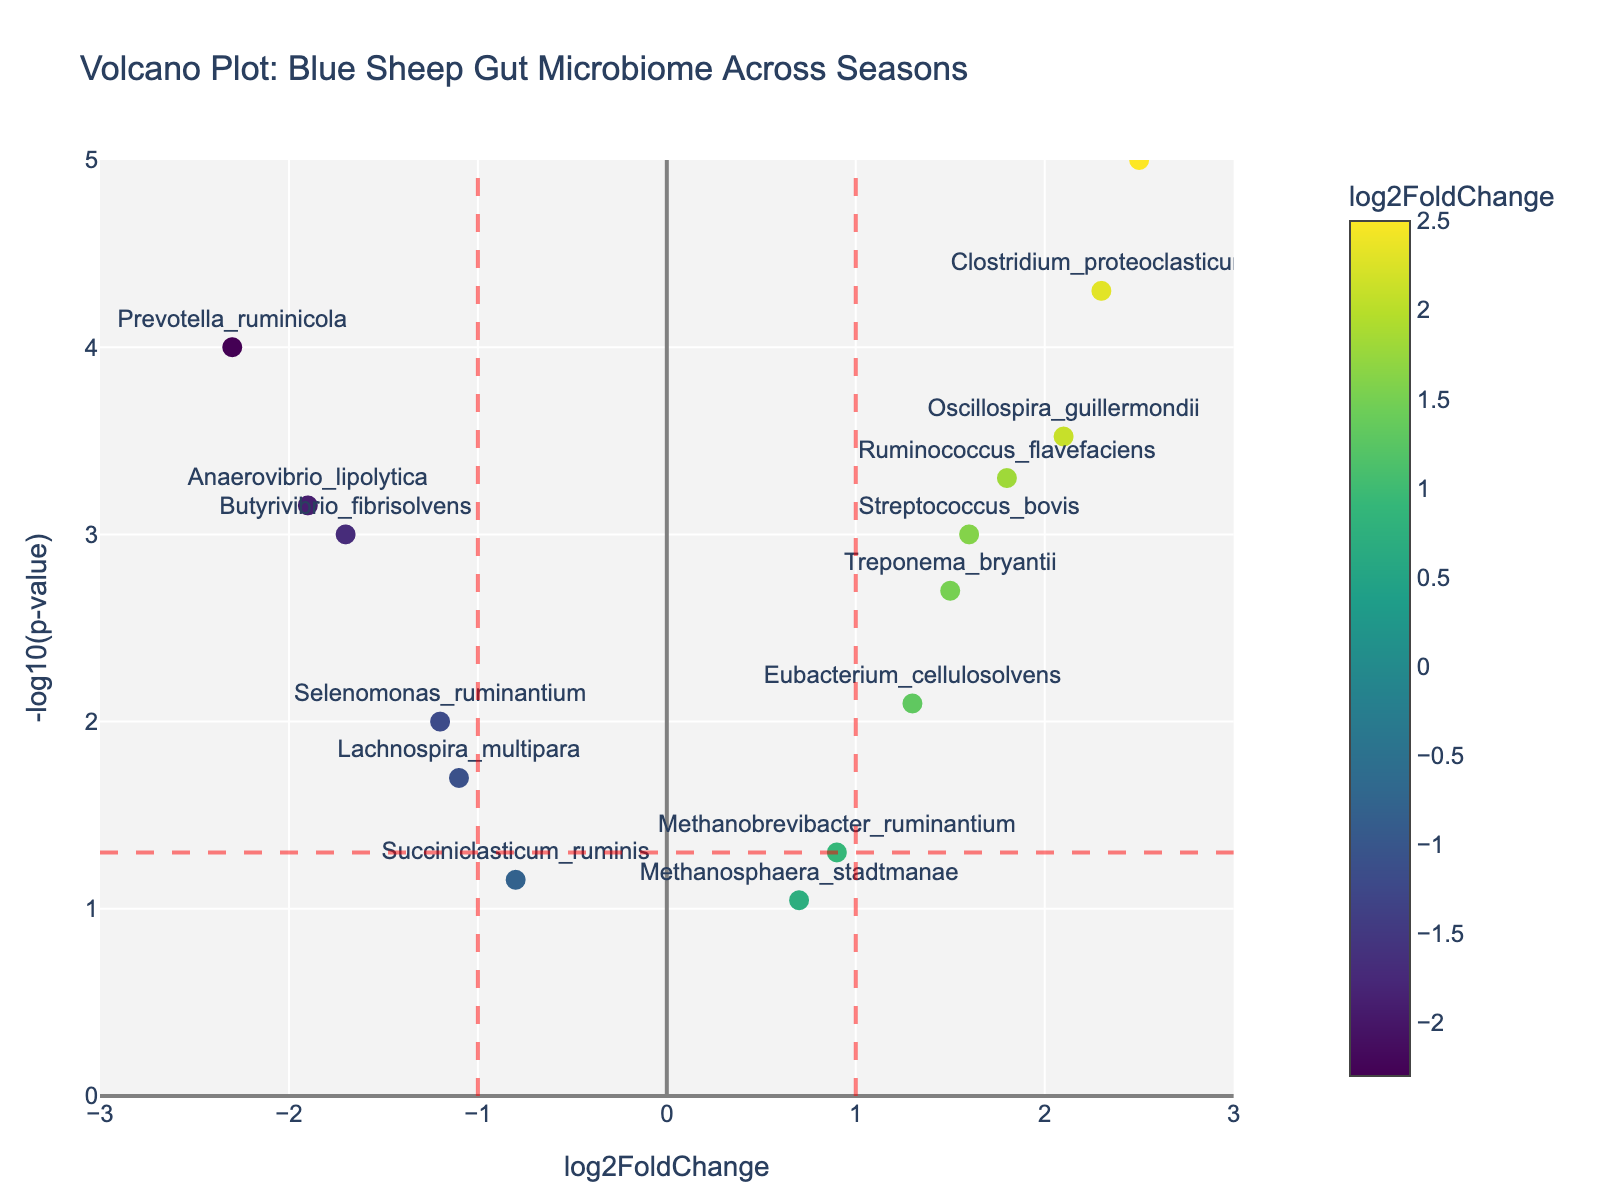What is the title of the Volcano Plot? The title is clearly displayed at the top of the plot.
Answer: Volcano Plot: Blue Sheep Gut Microbiome Across Seasons How many data points are above the horizontal red dashed line? This requires counting all the markers above the horizontal red dashed line, which represents the p-value threshold of 0.05 on a –log10 scale of 1.3.
Answer: 10 Which gene has the highest log2FoldChange value? Identify the marker with the highest x-coordinate (log2FoldChange) value on the plot.
Answer: Fibrobacter_succinogenes What is the log2FoldChange range shown on the x-axis? Look at the minimum and maximum values on the x-axis.
Answer: -3 to 3 How is the log2FoldChange of Methanobrevibacter_ruminantium compared to Fibrobacter_succinogenes? Compare their coordinates on the x-axis. The log2FoldChange for Methanobrevibacter_ruminantium is 0.9, while that for Fibrobacter_succinogenes is 2.5, making the latter higher.
Answer: Lower How many genes have a log2FoldChange value greater than 1? Count the number of genes with x-coordinates (log2FoldChange) greater than 1.
Answer: 5 What does the color gradient represent in the plot? The color gradient (Viridis) displayed in the color bar shows the log2FoldChange values.
Answer: log2FoldChange Which gene has the smallest p-value, and what is its -log10(p-value)? Identify the marker with the highest y-coordinate (–log10(pvalue)); this corresponds to the smallest p-value. The gene is Fibrobacter_succinogenes with a -log10(p-value) of 5.
Answer: Fibrobacter_succinogenes, 5 Which genes fall between the vertical dashed red lines within a log2FoldChange of -1 to 1? Locate the data points between the two red dashed lines at log2FoldChange values of -1 and 1.
Answer: Methanobrevibacter_ruminantium, Succiniclasticum_ruminis, Methanosphaera_stadtmanae, Selenomonas_ruminantium, Lachnospira_multipara What is the significance threshold for p-values in this plot? The horizontal red dashed line indicates the p-value threshold, where -log10(p-value) is 1.3, corresponding to p = 0.05.
Answer: 0.05 